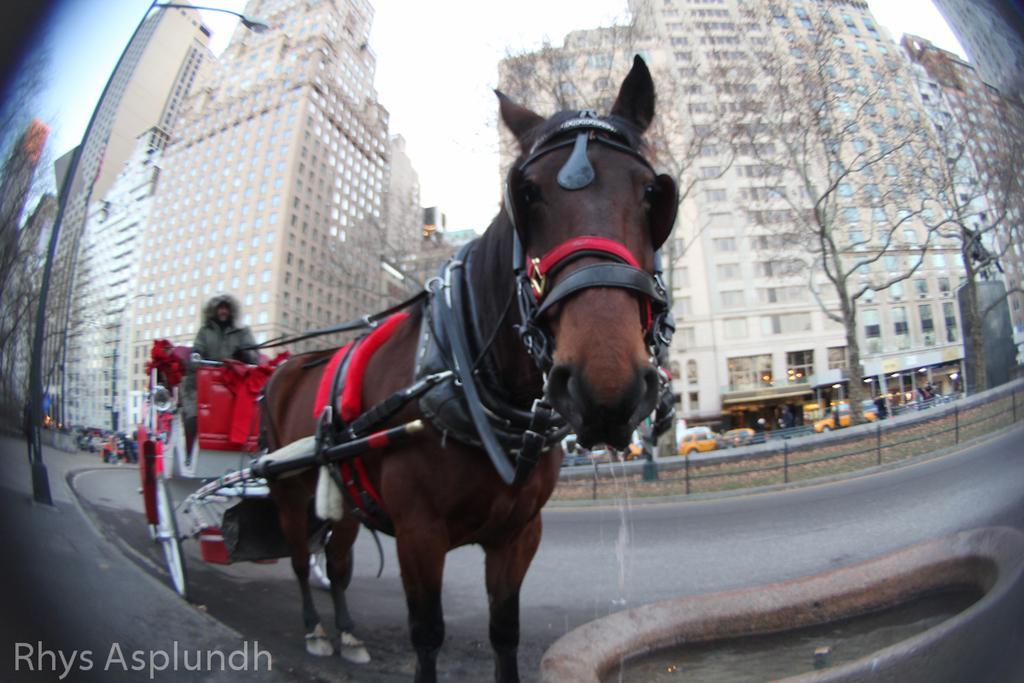How would you summarize this image in a sentence or two? In the middle of the image we can see a horse and cart, in the cart a person is sitting. Behind the cart there is fencing. Behind the fencing there are some trees and vehicles on the road. At the top of the image there are some buildings. Behind the buildings there is sky, on the left side of the image there is a pole. 